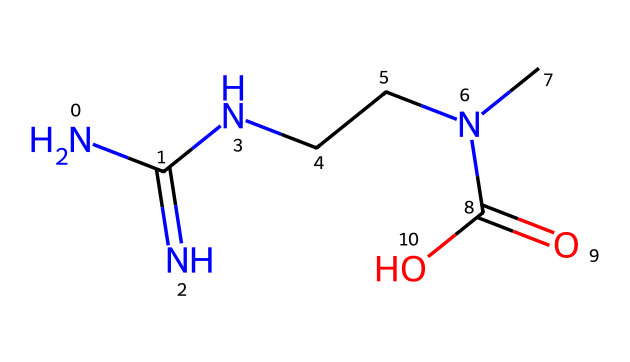What is the molecular formula of this compound? By examining the chemical structure represented by the SMILES notation, we can count the number of each type of atom in the structure: 4 carbon (C), 10 hydrogen (H), 4 nitrogen (N), and 2 oxygen (O) atoms, giving us the molecular formula C4H10N4O2.
Answer: C4H10N4O2 How many nitrogen atoms are present? Upon analysis of the structure, the SMILES representation includes four nitrogen (N) atoms, indicated by the letter "N."
Answer: 4 What functional groups are present in this structure? The chemical contains an amine group (indicated by -NH2) and a carboxylic acid group (indicated by -COOH). These groups are identifiable from the arrangement of nitrogen and carbon with the oxygen double bond in the structure.
Answer: amine and carboxylic acid What is the role of creatine supplements in football? Creatine is known to enhance muscle performance and increase energy levels, particularly in short bursts of high-intensity activities such as those found in football. This usage is derived from its biochemical role in energy production in muscle cells.
Answer: enhance performance Is this compound a food additive? Yes, creatine is classified as a food additive commonly used in dietary supplements aimed primarily at athletes and bodybuilders to improve physical performance and recovery.
Answer: Yes How many carbon atoms are in the side chains? In the structure, there are 4 carbon atoms total, where 2 are part of the side chain (-N(C)C) connected to the nitrogen atom, and the remaining are part of the main chain leading to the carboxylic group.
Answer: 2 